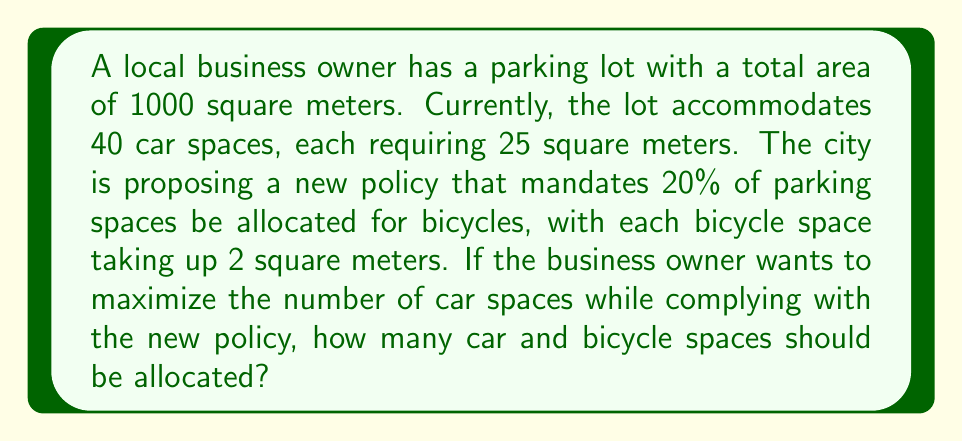Can you answer this question? Let's approach this step-by-step:

1) First, let's define our variables:
   $x$ = number of car spaces
   $y$ = number of bicycle spaces

2) We know that the total area is 1000 square meters:
   $$25x + 2y = 1000$$

3) The new policy requires that bicycle spaces be 20% of the total spaces:
   $$y = 0.2(x + y)$$

4) Solving for $y$ in terms of $x$:
   $$y = 0.25x$$

5) Substituting this into our area equation:
   $$25x + 2(0.25x) = 1000$$
   $$25x + 0.5x = 1000$$
   $$25.5x = 1000$$

6) Solving for $x$:
   $$x = \frac{1000}{25.5} \approx 39.22$$

7) Since we can't have fractional parking spaces, we round down to 39 car spaces.

8) Calculate bicycle spaces:
   $$y = 0.25(39) = 9.75$$
   Rounding up to 10 bicycle spaces to meet the 20% requirement.

9) Verify:
   Total spaces: 39 + 10 = 49
   Bicycle spaces percentage: $\frac{10}{49} \approx 20.4\%$ (meets requirement)
   Area used: $39(25) + 10(2) = 995$ square meters (within total area)
Answer: 39 car spaces, 10 bicycle spaces 